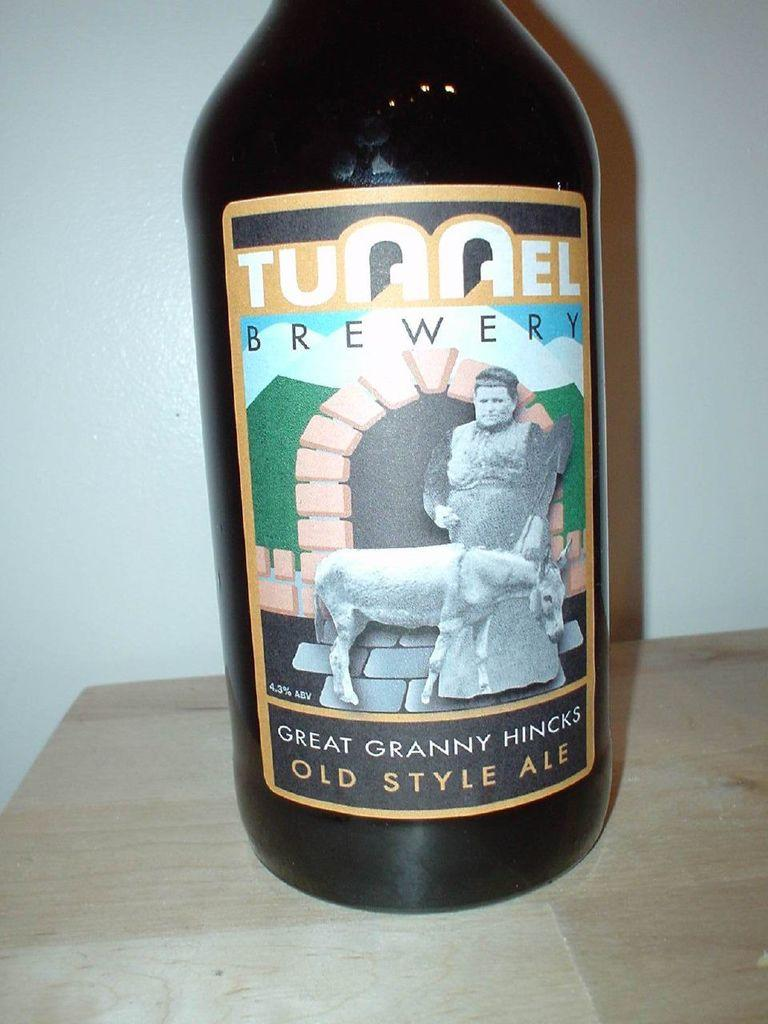<image>
Present a compact description of the photo's key features. The bottle contains old style ale from Tunnel Brewery. 